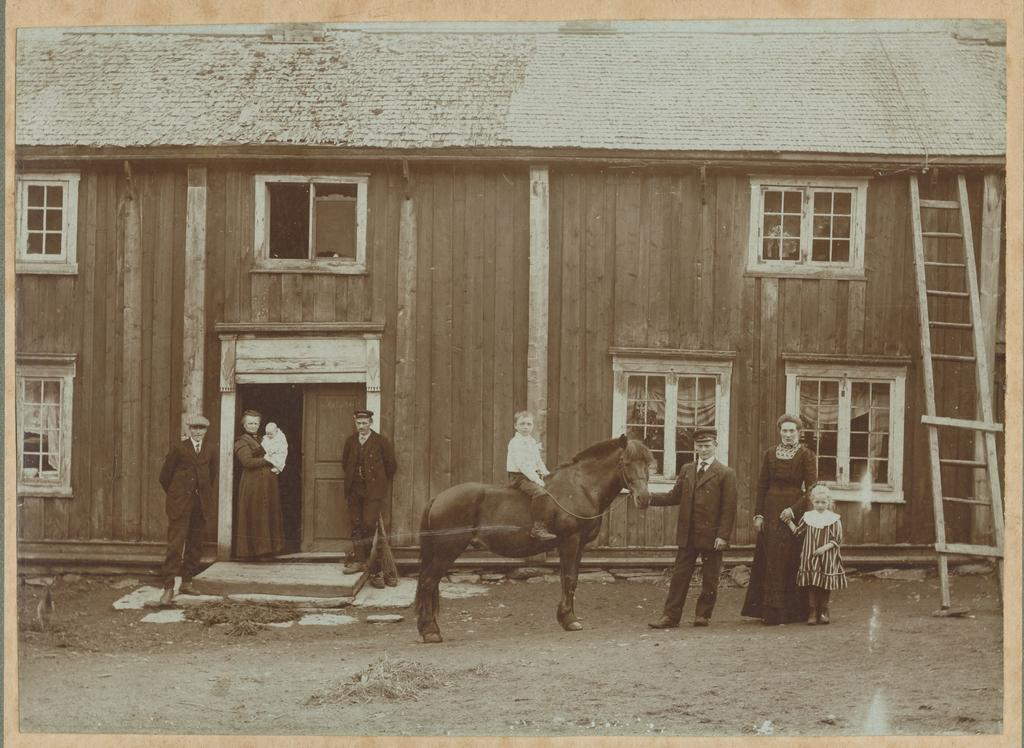What are the people in the image doing? There are persons standing in the image. What is the boy doing in the image? The boy is sitting on a horse. How is the boy interacting with the horse? The boy is touching the horse. What can be seen in the background of the image? There is a house with windows and a ladder leading to the house in the background. What type of tomatoes can be seen growing in the bedroom in the image? There are no tomatoes or bedrooms present in the image. 